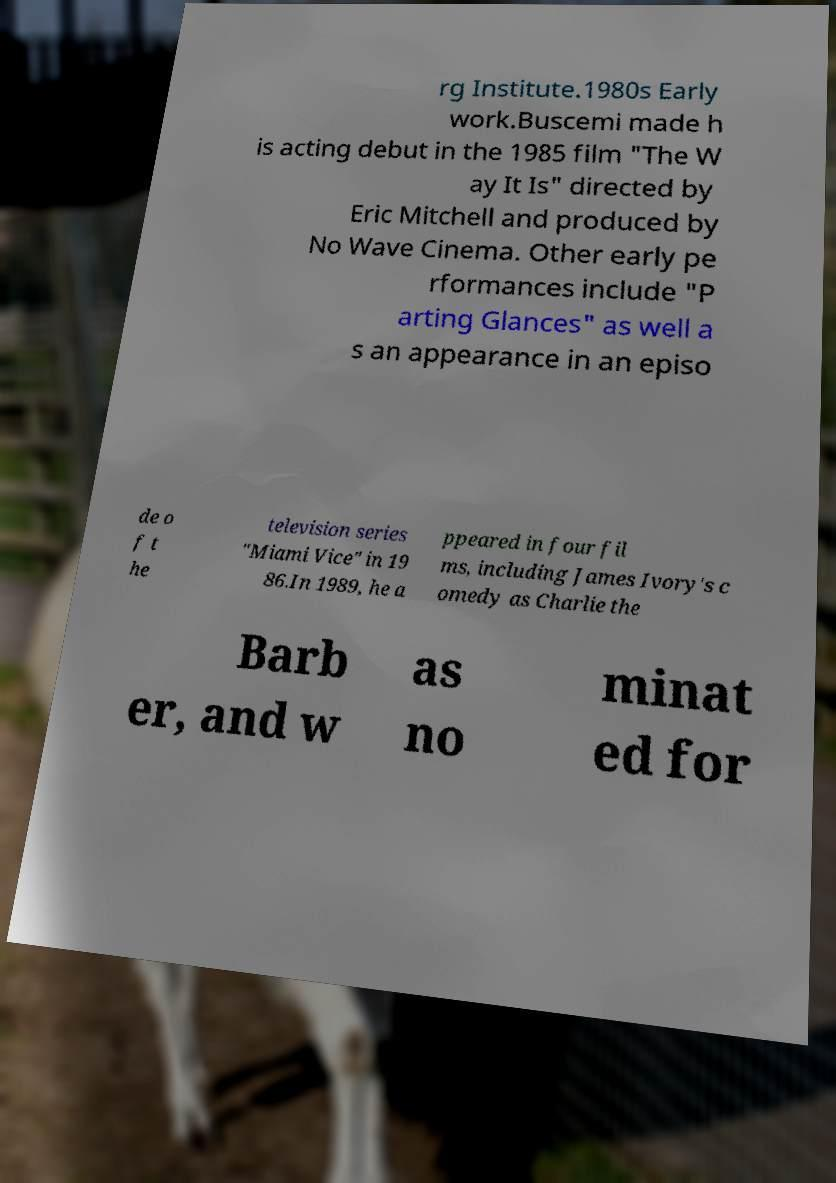Could you extract and type out the text from this image? rg Institute.1980s Early work.Buscemi made h is acting debut in the 1985 film "The W ay It Is" directed by Eric Mitchell and produced by No Wave Cinema. Other early pe rformances include "P arting Glances" as well a s an appearance in an episo de o f t he television series "Miami Vice" in 19 86.In 1989, he a ppeared in four fil ms, including James Ivory's c omedy as Charlie the Barb er, and w as no minat ed for 